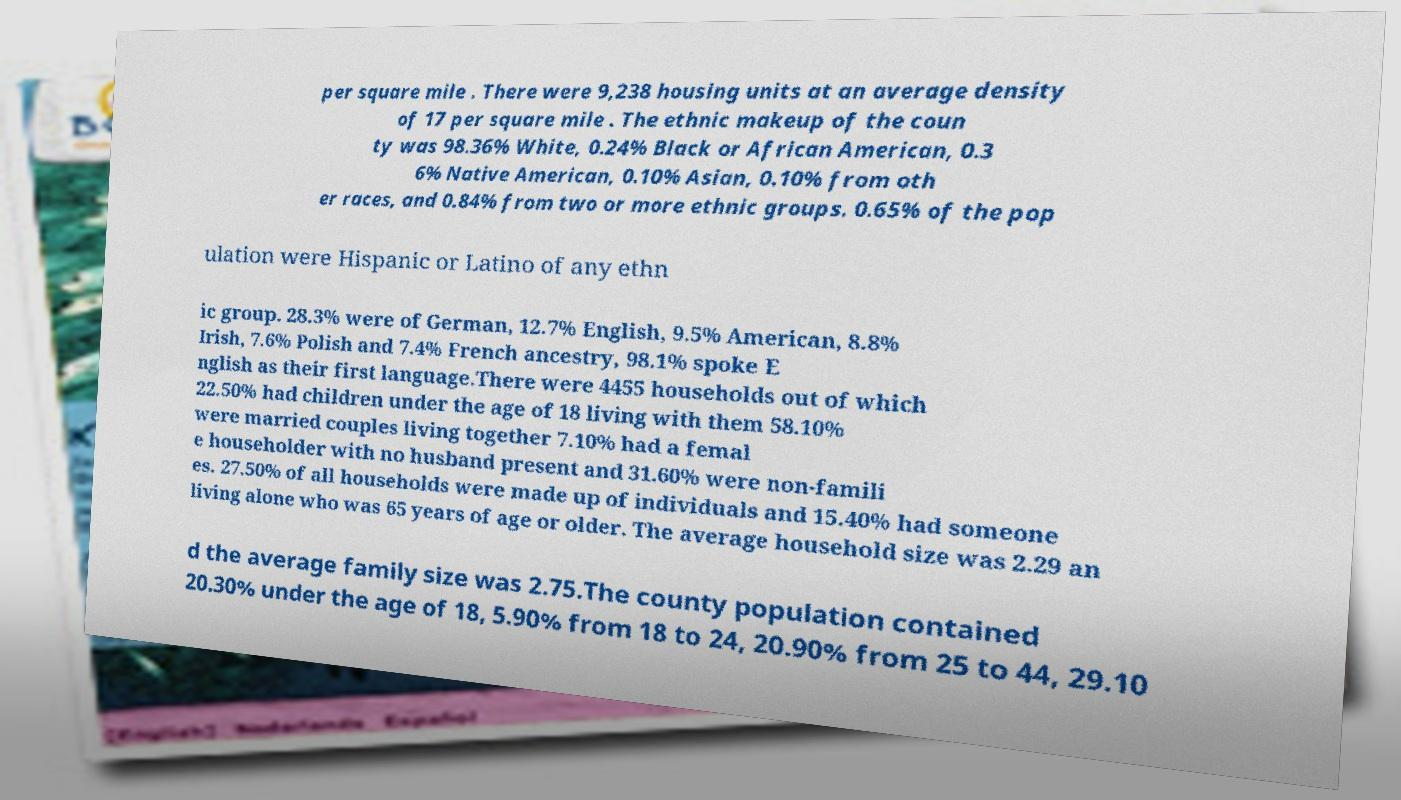Can you read and provide the text displayed in the image?This photo seems to have some interesting text. Can you extract and type it out for me? per square mile . There were 9,238 housing units at an average density of 17 per square mile . The ethnic makeup of the coun ty was 98.36% White, 0.24% Black or African American, 0.3 6% Native American, 0.10% Asian, 0.10% from oth er races, and 0.84% from two or more ethnic groups. 0.65% of the pop ulation were Hispanic or Latino of any ethn ic group. 28.3% were of German, 12.7% English, 9.5% American, 8.8% Irish, 7.6% Polish and 7.4% French ancestry, 98.1% spoke E nglish as their first language.There were 4455 households out of which 22.50% had children under the age of 18 living with them 58.10% were married couples living together 7.10% had a femal e householder with no husband present and 31.60% were non-famili es. 27.50% of all households were made up of individuals and 15.40% had someone living alone who was 65 years of age or older. The average household size was 2.29 an d the average family size was 2.75.The county population contained 20.30% under the age of 18, 5.90% from 18 to 24, 20.90% from 25 to 44, 29.10 